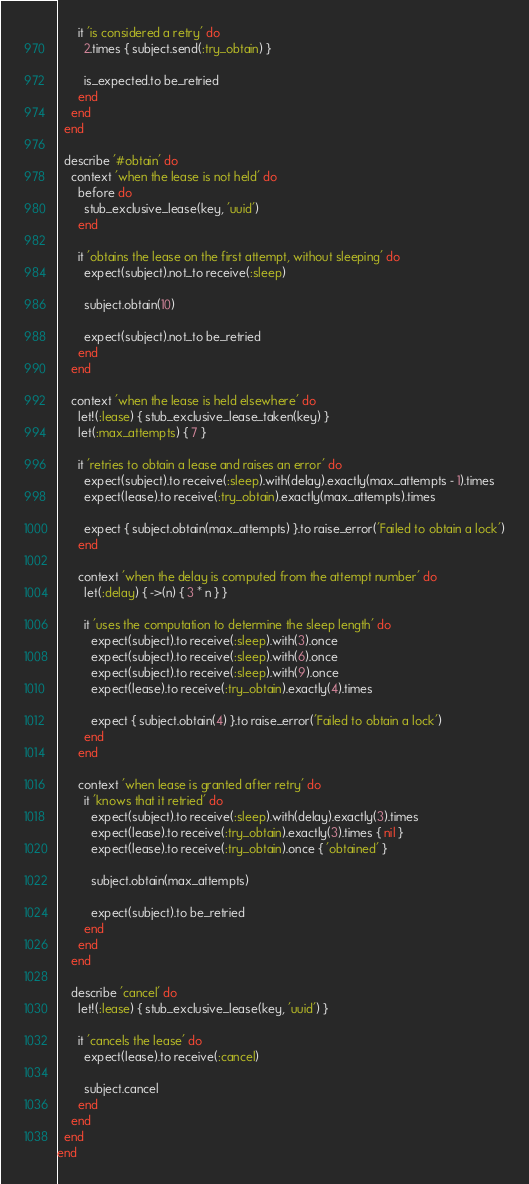<code> <loc_0><loc_0><loc_500><loc_500><_Ruby_>      it 'is considered a retry' do
        2.times { subject.send(:try_obtain) }

        is_expected.to be_retried
      end
    end
  end

  describe '#obtain' do
    context 'when the lease is not held' do
      before do
        stub_exclusive_lease(key, 'uuid')
      end

      it 'obtains the lease on the first attempt, without sleeping' do
        expect(subject).not_to receive(:sleep)

        subject.obtain(10)

        expect(subject).not_to be_retried
      end
    end

    context 'when the lease is held elsewhere' do
      let!(:lease) { stub_exclusive_lease_taken(key) }
      let(:max_attempts) { 7 }

      it 'retries to obtain a lease and raises an error' do
        expect(subject).to receive(:sleep).with(delay).exactly(max_attempts - 1).times
        expect(lease).to receive(:try_obtain).exactly(max_attempts).times

        expect { subject.obtain(max_attempts) }.to raise_error('Failed to obtain a lock')
      end

      context 'when the delay is computed from the attempt number' do
        let(:delay) { ->(n) { 3 * n } }

        it 'uses the computation to determine the sleep length' do
          expect(subject).to receive(:sleep).with(3).once
          expect(subject).to receive(:sleep).with(6).once
          expect(subject).to receive(:sleep).with(9).once
          expect(lease).to receive(:try_obtain).exactly(4).times

          expect { subject.obtain(4) }.to raise_error('Failed to obtain a lock')
        end
      end

      context 'when lease is granted after retry' do
        it 'knows that it retried' do
          expect(subject).to receive(:sleep).with(delay).exactly(3).times
          expect(lease).to receive(:try_obtain).exactly(3).times { nil }
          expect(lease).to receive(:try_obtain).once { 'obtained' }

          subject.obtain(max_attempts)

          expect(subject).to be_retried
        end
      end
    end

    describe 'cancel' do
      let!(:lease) { stub_exclusive_lease(key, 'uuid') }

      it 'cancels the lease' do
        expect(lease).to receive(:cancel)

        subject.cancel
      end
    end
  end
end
</code> 